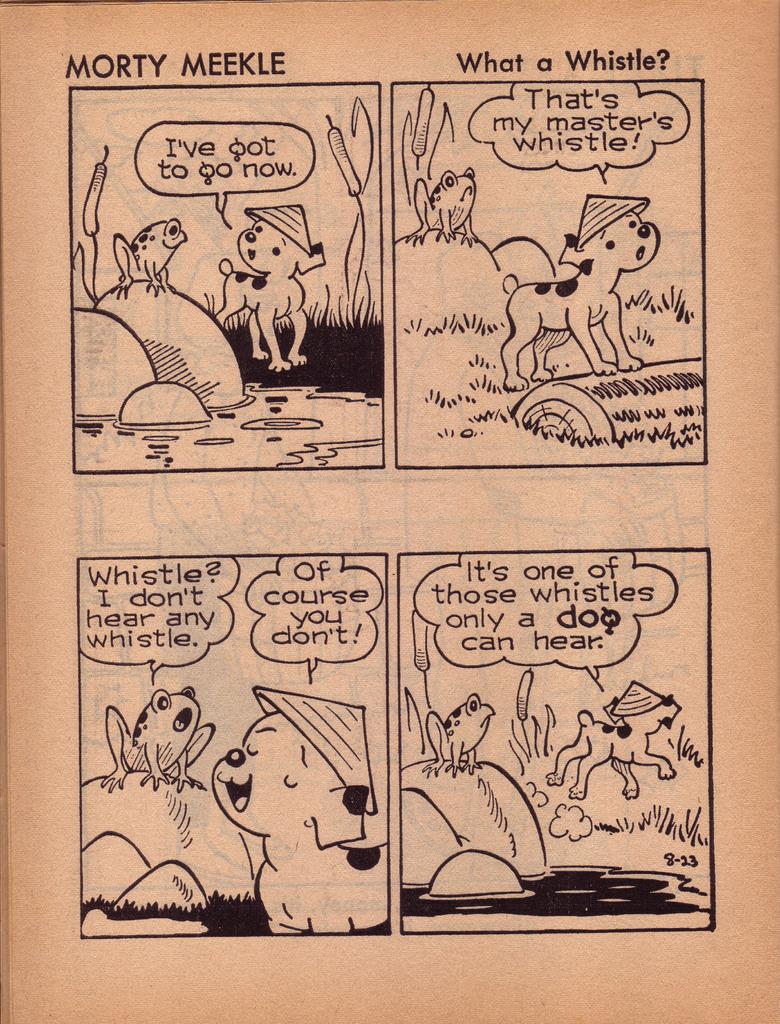Whats the conic about?
Your response must be concise. Whistle. 